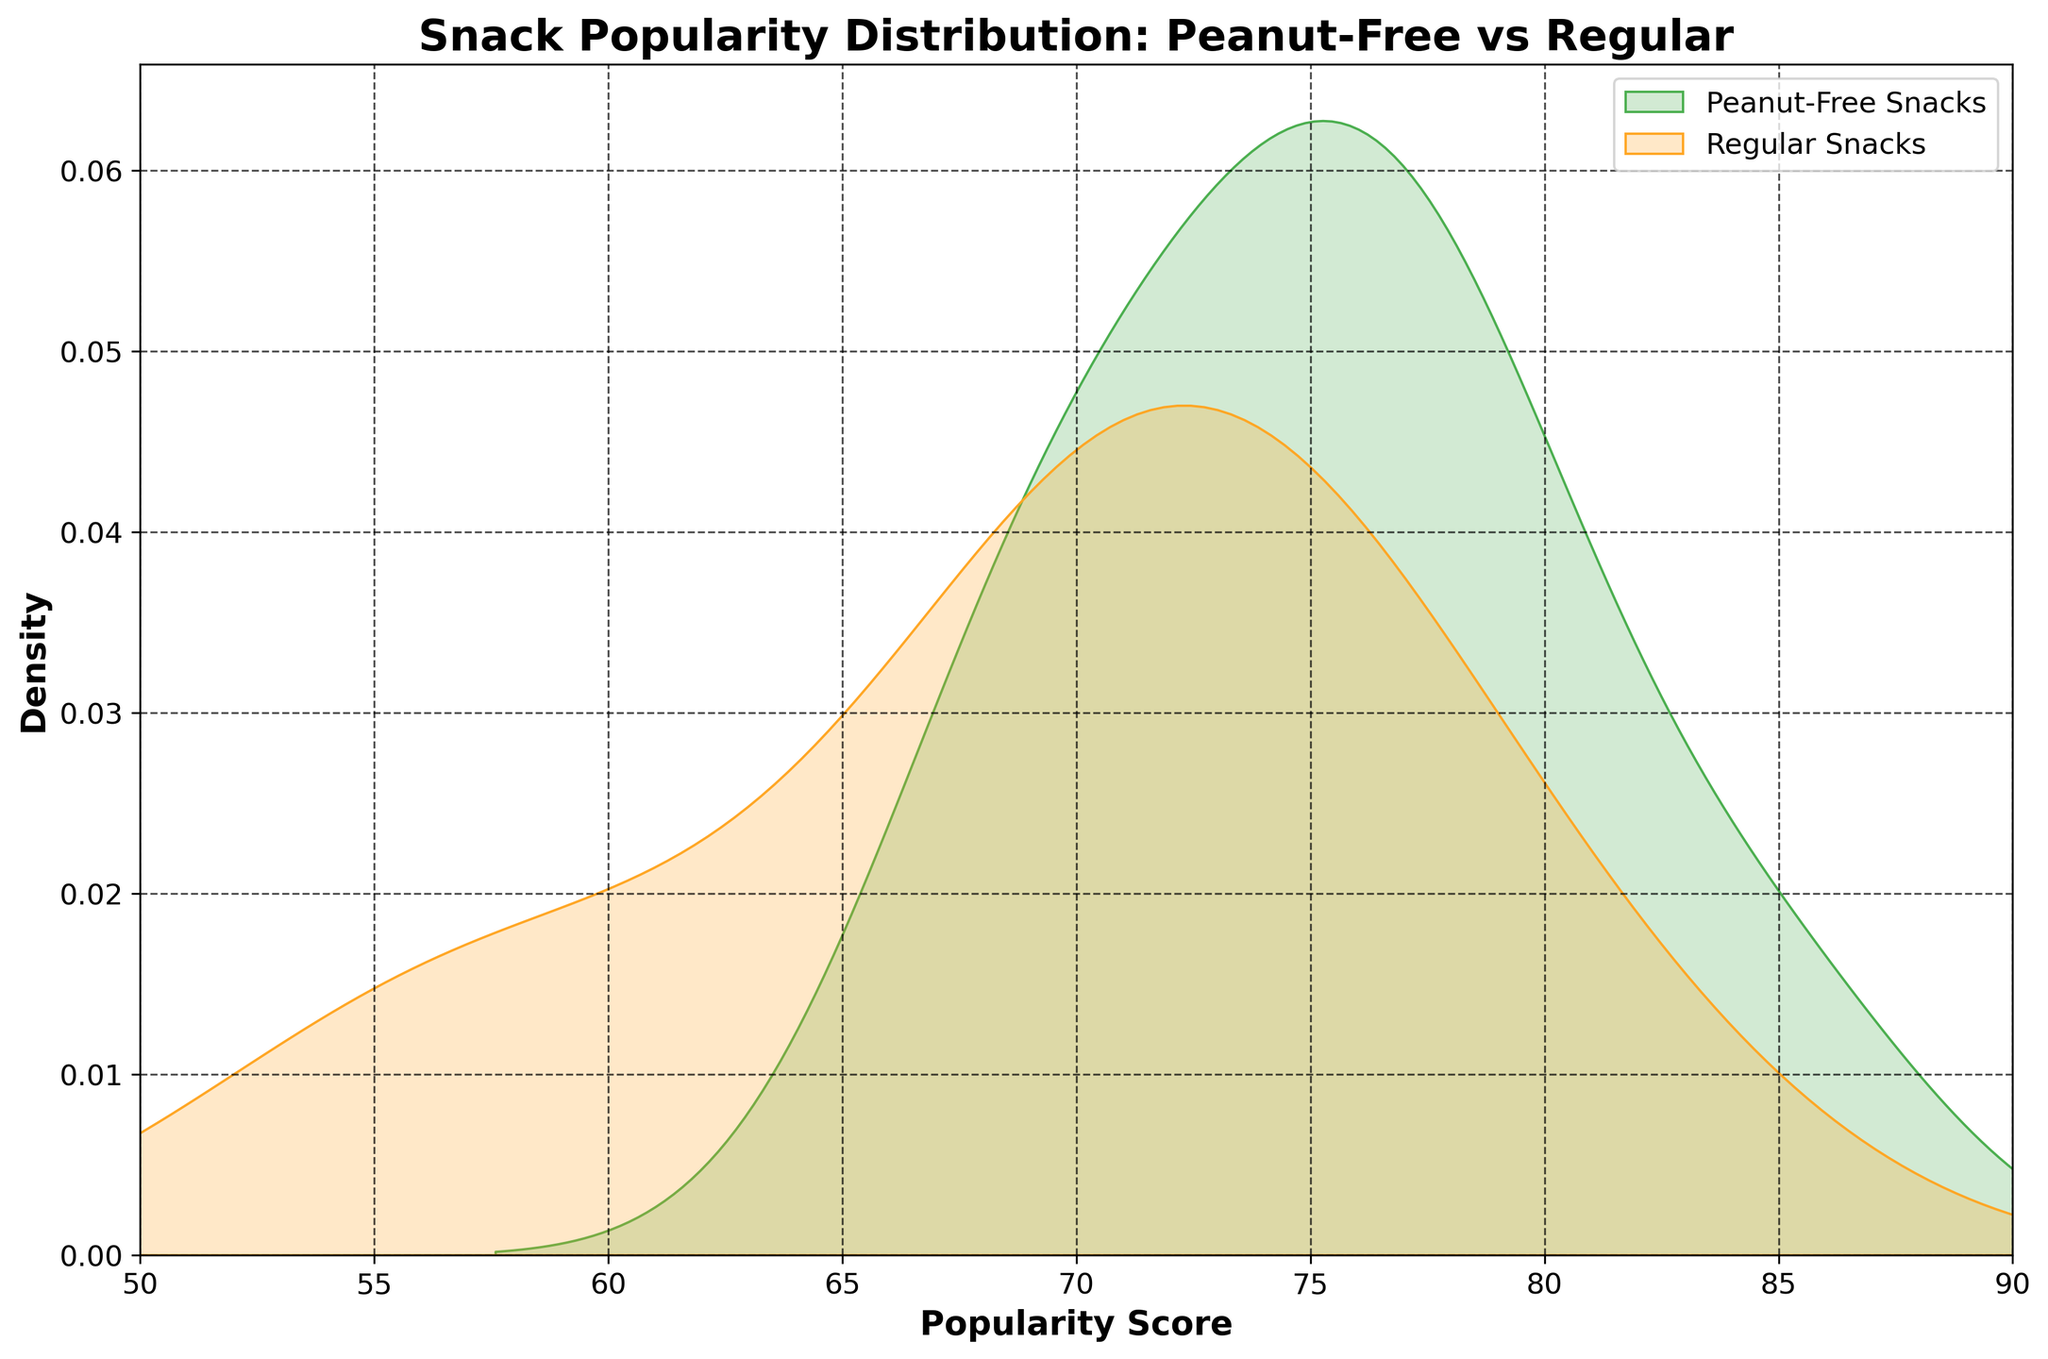What's the title of the figure? The title of the figure is displayed at the top of the plot. It reads "Snack Popularity Distribution: Peanut-Free vs Regular".
Answer: Snack Popularity Distribution: Peanut-Free vs Regular What does the x-axis represent? The x-axis label indicates what is being measured along this axis. It is labeled "Popularity Score".
Answer: Popularity Score Which color represents peanut-free snacks? Different colors are used to represent different categories. The green color represents peanut-free snacks in the plot.
Answer: Green Which type of snacks has the higher peak density? By observing the peaks of the density curves, the peanut-free snacks (green) have a higher peak density compared to the regular snacks (orange).
Answer: Peanut-free snacks What is the approximate range of popularity scores for peanut-free snacks? The x-axis shows the range covered by the green curve, which represents peanut-free snacks. The curve spans from approximately 65 to 85.
Answer: 65 to 85 Which snack type has more variation in popularity scores? Variation in popularity scores is indicated by the width of the density curve. The peanut-free snacks have a slightly wider curve, indicating more variation compared to regular snacks.
Answer: Peanut-free snacks Which popularity score has the highest density for peanut-free snacks? The peak of the green density curve corresponds to the highest density point for peanut-free snacks. This peak appears around a score of 75.
Answer: 75 Comparing the peaks, do peanut-free or regular snacks reach higher density values? By comparing the peaks of both curves, the green curve of peanut-free snacks reaches higher density values than the orange curve of regular snacks.
Answer: Peanut-free snacks What is the approximate density value at the peak for regular snacks? The peak of the orange curve represents the highest density value for regular snacks, which is approximately 0.035.
Answer: 0.035 Is there any overlap in the popularity scores between peanut-free and regular snacks? To determine overlap, we look where both density curves exist on the x-axis. They both display density values between approximately 65 and 76.
Answer: Yes 